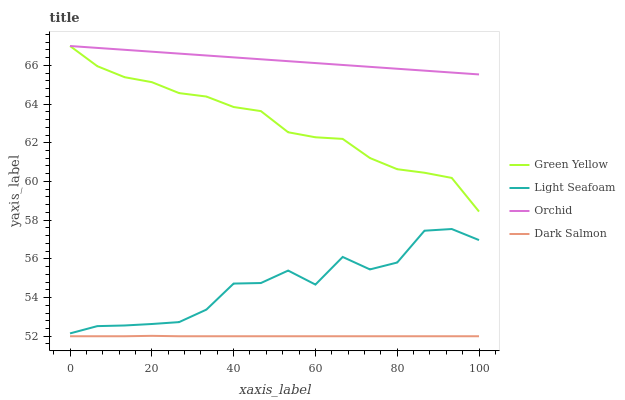Does Dark Salmon have the minimum area under the curve?
Answer yes or no. Yes. Does Orchid have the maximum area under the curve?
Answer yes or no. Yes. Does Light Seafoam have the minimum area under the curve?
Answer yes or no. No. Does Light Seafoam have the maximum area under the curve?
Answer yes or no. No. Is Orchid the smoothest?
Answer yes or no. Yes. Is Light Seafoam the roughest?
Answer yes or no. Yes. Is Dark Salmon the smoothest?
Answer yes or no. No. Is Dark Salmon the roughest?
Answer yes or no. No. Does Dark Salmon have the lowest value?
Answer yes or no. Yes. Does Light Seafoam have the lowest value?
Answer yes or no. No. Does Orchid have the highest value?
Answer yes or no. Yes. Does Light Seafoam have the highest value?
Answer yes or no. No. Is Dark Salmon less than Orchid?
Answer yes or no. Yes. Is Orchid greater than Light Seafoam?
Answer yes or no. Yes. Does Green Yellow intersect Orchid?
Answer yes or no. Yes. Is Green Yellow less than Orchid?
Answer yes or no. No. Is Green Yellow greater than Orchid?
Answer yes or no. No. Does Dark Salmon intersect Orchid?
Answer yes or no. No. 